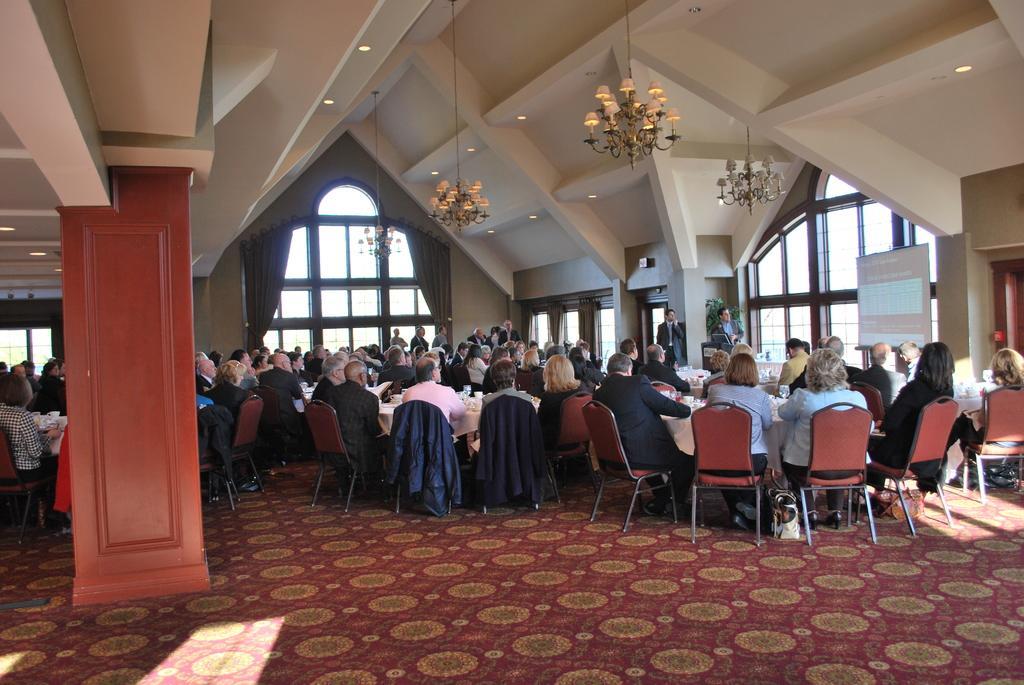In one or two sentences, can you explain what this image depicts? This is an inside view. Here I can see many people sitting on the chairs facing to the back side. There are many tables covered with white color clothes. On the left side there is a red color pillar. In the background two men are standing and also I can see few windows to the wall. At the top of the image I can see few lights and chandeliers. 